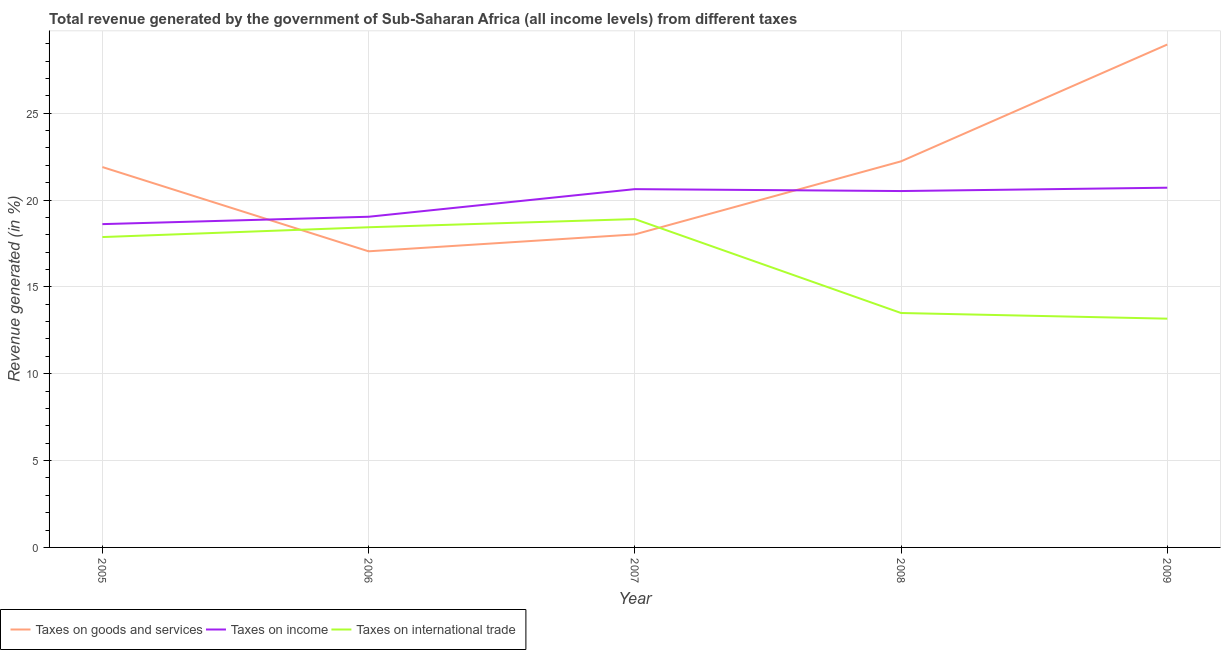Is the number of lines equal to the number of legend labels?
Offer a terse response. Yes. What is the percentage of revenue generated by taxes on income in 2006?
Make the answer very short. 19.04. Across all years, what is the maximum percentage of revenue generated by taxes on goods and services?
Provide a short and direct response. 28.95. Across all years, what is the minimum percentage of revenue generated by taxes on goods and services?
Your answer should be compact. 17.05. What is the total percentage of revenue generated by tax on international trade in the graph?
Your answer should be compact. 81.87. What is the difference between the percentage of revenue generated by taxes on income in 2006 and that in 2008?
Your response must be concise. -1.48. What is the difference between the percentage of revenue generated by taxes on income in 2008 and the percentage of revenue generated by tax on international trade in 2006?
Your response must be concise. 2.08. What is the average percentage of revenue generated by taxes on goods and services per year?
Your answer should be very brief. 21.63. In the year 2008, what is the difference between the percentage of revenue generated by taxes on goods and services and percentage of revenue generated by tax on international trade?
Provide a short and direct response. 8.73. What is the ratio of the percentage of revenue generated by taxes on goods and services in 2007 to that in 2009?
Your response must be concise. 0.62. What is the difference between the highest and the second highest percentage of revenue generated by tax on international trade?
Make the answer very short. 0.47. What is the difference between the highest and the lowest percentage of revenue generated by taxes on income?
Provide a succinct answer. 2.1. How many lines are there?
Give a very brief answer. 3. How many years are there in the graph?
Your answer should be very brief. 5. Are the values on the major ticks of Y-axis written in scientific E-notation?
Your answer should be very brief. No. Does the graph contain any zero values?
Your answer should be very brief. No. Where does the legend appear in the graph?
Provide a succinct answer. Bottom left. How many legend labels are there?
Ensure brevity in your answer.  3. How are the legend labels stacked?
Give a very brief answer. Horizontal. What is the title of the graph?
Provide a short and direct response. Total revenue generated by the government of Sub-Saharan Africa (all income levels) from different taxes. What is the label or title of the Y-axis?
Offer a terse response. Revenue generated (in %). What is the Revenue generated (in %) of Taxes on goods and services in 2005?
Ensure brevity in your answer.  21.9. What is the Revenue generated (in %) in Taxes on income in 2005?
Provide a short and direct response. 18.61. What is the Revenue generated (in %) in Taxes on international trade in 2005?
Provide a succinct answer. 17.87. What is the Revenue generated (in %) in Taxes on goods and services in 2006?
Ensure brevity in your answer.  17.05. What is the Revenue generated (in %) in Taxes on income in 2006?
Your response must be concise. 19.04. What is the Revenue generated (in %) in Taxes on international trade in 2006?
Make the answer very short. 18.43. What is the Revenue generated (in %) of Taxes on goods and services in 2007?
Your answer should be compact. 18.02. What is the Revenue generated (in %) of Taxes on income in 2007?
Provide a short and direct response. 20.63. What is the Revenue generated (in %) in Taxes on international trade in 2007?
Ensure brevity in your answer.  18.9. What is the Revenue generated (in %) of Taxes on goods and services in 2008?
Offer a terse response. 22.23. What is the Revenue generated (in %) in Taxes on income in 2008?
Give a very brief answer. 20.52. What is the Revenue generated (in %) in Taxes on international trade in 2008?
Your answer should be compact. 13.5. What is the Revenue generated (in %) in Taxes on goods and services in 2009?
Give a very brief answer. 28.95. What is the Revenue generated (in %) in Taxes on income in 2009?
Your answer should be compact. 20.71. What is the Revenue generated (in %) in Taxes on international trade in 2009?
Provide a short and direct response. 13.17. Across all years, what is the maximum Revenue generated (in %) of Taxes on goods and services?
Your answer should be compact. 28.95. Across all years, what is the maximum Revenue generated (in %) in Taxes on income?
Make the answer very short. 20.71. Across all years, what is the maximum Revenue generated (in %) of Taxes on international trade?
Provide a short and direct response. 18.9. Across all years, what is the minimum Revenue generated (in %) in Taxes on goods and services?
Provide a succinct answer. 17.05. Across all years, what is the minimum Revenue generated (in %) of Taxes on income?
Make the answer very short. 18.61. Across all years, what is the minimum Revenue generated (in %) of Taxes on international trade?
Your answer should be compact. 13.17. What is the total Revenue generated (in %) in Taxes on goods and services in the graph?
Offer a very short reply. 108.14. What is the total Revenue generated (in %) in Taxes on income in the graph?
Offer a very short reply. 99.5. What is the total Revenue generated (in %) of Taxes on international trade in the graph?
Provide a short and direct response. 81.87. What is the difference between the Revenue generated (in %) in Taxes on goods and services in 2005 and that in 2006?
Keep it short and to the point. 4.85. What is the difference between the Revenue generated (in %) of Taxes on income in 2005 and that in 2006?
Offer a very short reply. -0.42. What is the difference between the Revenue generated (in %) of Taxes on international trade in 2005 and that in 2006?
Keep it short and to the point. -0.57. What is the difference between the Revenue generated (in %) in Taxes on goods and services in 2005 and that in 2007?
Give a very brief answer. 3.88. What is the difference between the Revenue generated (in %) in Taxes on income in 2005 and that in 2007?
Your answer should be very brief. -2.01. What is the difference between the Revenue generated (in %) in Taxes on international trade in 2005 and that in 2007?
Ensure brevity in your answer.  -1.04. What is the difference between the Revenue generated (in %) of Taxes on goods and services in 2005 and that in 2008?
Provide a short and direct response. -0.33. What is the difference between the Revenue generated (in %) in Taxes on income in 2005 and that in 2008?
Your answer should be compact. -1.9. What is the difference between the Revenue generated (in %) of Taxes on international trade in 2005 and that in 2008?
Provide a short and direct response. 4.37. What is the difference between the Revenue generated (in %) in Taxes on goods and services in 2005 and that in 2009?
Your answer should be compact. -7.05. What is the difference between the Revenue generated (in %) in Taxes on income in 2005 and that in 2009?
Your answer should be very brief. -2.1. What is the difference between the Revenue generated (in %) of Taxes on international trade in 2005 and that in 2009?
Your response must be concise. 4.7. What is the difference between the Revenue generated (in %) of Taxes on goods and services in 2006 and that in 2007?
Keep it short and to the point. -0.97. What is the difference between the Revenue generated (in %) of Taxes on income in 2006 and that in 2007?
Keep it short and to the point. -1.59. What is the difference between the Revenue generated (in %) of Taxes on international trade in 2006 and that in 2007?
Make the answer very short. -0.47. What is the difference between the Revenue generated (in %) in Taxes on goods and services in 2006 and that in 2008?
Offer a terse response. -5.18. What is the difference between the Revenue generated (in %) in Taxes on income in 2006 and that in 2008?
Your response must be concise. -1.48. What is the difference between the Revenue generated (in %) in Taxes on international trade in 2006 and that in 2008?
Ensure brevity in your answer.  4.94. What is the difference between the Revenue generated (in %) of Taxes on goods and services in 2006 and that in 2009?
Make the answer very short. -11.9. What is the difference between the Revenue generated (in %) of Taxes on income in 2006 and that in 2009?
Provide a succinct answer. -1.67. What is the difference between the Revenue generated (in %) in Taxes on international trade in 2006 and that in 2009?
Offer a very short reply. 5.26. What is the difference between the Revenue generated (in %) of Taxes on goods and services in 2007 and that in 2008?
Your answer should be compact. -4.21. What is the difference between the Revenue generated (in %) of Taxes on income in 2007 and that in 2008?
Make the answer very short. 0.11. What is the difference between the Revenue generated (in %) of Taxes on international trade in 2007 and that in 2008?
Your answer should be very brief. 5.41. What is the difference between the Revenue generated (in %) in Taxes on goods and services in 2007 and that in 2009?
Your response must be concise. -10.93. What is the difference between the Revenue generated (in %) of Taxes on income in 2007 and that in 2009?
Your response must be concise. -0.08. What is the difference between the Revenue generated (in %) of Taxes on international trade in 2007 and that in 2009?
Offer a very short reply. 5.73. What is the difference between the Revenue generated (in %) of Taxes on goods and services in 2008 and that in 2009?
Provide a short and direct response. -6.72. What is the difference between the Revenue generated (in %) of Taxes on income in 2008 and that in 2009?
Make the answer very short. -0.19. What is the difference between the Revenue generated (in %) in Taxes on international trade in 2008 and that in 2009?
Your answer should be compact. 0.33. What is the difference between the Revenue generated (in %) of Taxes on goods and services in 2005 and the Revenue generated (in %) of Taxes on income in 2006?
Offer a terse response. 2.86. What is the difference between the Revenue generated (in %) of Taxes on goods and services in 2005 and the Revenue generated (in %) of Taxes on international trade in 2006?
Offer a very short reply. 3.47. What is the difference between the Revenue generated (in %) in Taxes on income in 2005 and the Revenue generated (in %) in Taxes on international trade in 2006?
Offer a very short reply. 0.18. What is the difference between the Revenue generated (in %) in Taxes on goods and services in 2005 and the Revenue generated (in %) in Taxes on income in 2007?
Your answer should be very brief. 1.27. What is the difference between the Revenue generated (in %) of Taxes on goods and services in 2005 and the Revenue generated (in %) of Taxes on international trade in 2007?
Offer a very short reply. 3. What is the difference between the Revenue generated (in %) in Taxes on income in 2005 and the Revenue generated (in %) in Taxes on international trade in 2007?
Provide a succinct answer. -0.29. What is the difference between the Revenue generated (in %) in Taxes on goods and services in 2005 and the Revenue generated (in %) in Taxes on income in 2008?
Make the answer very short. 1.38. What is the difference between the Revenue generated (in %) in Taxes on goods and services in 2005 and the Revenue generated (in %) in Taxes on international trade in 2008?
Provide a succinct answer. 8.4. What is the difference between the Revenue generated (in %) in Taxes on income in 2005 and the Revenue generated (in %) in Taxes on international trade in 2008?
Provide a succinct answer. 5.12. What is the difference between the Revenue generated (in %) in Taxes on goods and services in 2005 and the Revenue generated (in %) in Taxes on income in 2009?
Keep it short and to the point. 1.19. What is the difference between the Revenue generated (in %) in Taxes on goods and services in 2005 and the Revenue generated (in %) in Taxes on international trade in 2009?
Keep it short and to the point. 8.73. What is the difference between the Revenue generated (in %) in Taxes on income in 2005 and the Revenue generated (in %) in Taxes on international trade in 2009?
Offer a very short reply. 5.44. What is the difference between the Revenue generated (in %) in Taxes on goods and services in 2006 and the Revenue generated (in %) in Taxes on income in 2007?
Offer a very short reply. -3.58. What is the difference between the Revenue generated (in %) in Taxes on goods and services in 2006 and the Revenue generated (in %) in Taxes on international trade in 2007?
Make the answer very short. -1.86. What is the difference between the Revenue generated (in %) of Taxes on income in 2006 and the Revenue generated (in %) of Taxes on international trade in 2007?
Your answer should be very brief. 0.13. What is the difference between the Revenue generated (in %) of Taxes on goods and services in 2006 and the Revenue generated (in %) of Taxes on income in 2008?
Offer a very short reply. -3.47. What is the difference between the Revenue generated (in %) of Taxes on goods and services in 2006 and the Revenue generated (in %) of Taxes on international trade in 2008?
Offer a terse response. 3.55. What is the difference between the Revenue generated (in %) of Taxes on income in 2006 and the Revenue generated (in %) of Taxes on international trade in 2008?
Offer a very short reply. 5.54. What is the difference between the Revenue generated (in %) in Taxes on goods and services in 2006 and the Revenue generated (in %) in Taxes on income in 2009?
Offer a very short reply. -3.66. What is the difference between the Revenue generated (in %) of Taxes on goods and services in 2006 and the Revenue generated (in %) of Taxes on international trade in 2009?
Provide a short and direct response. 3.88. What is the difference between the Revenue generated (in %) of Taxes on income in 2006 and the Revenue generated (in %) of Taxes on international trade in 2009?
Ensure brevity in your answer.  5.87. What is the difference between the Revenue generated (in %) in Taxes on goods and services in 2007 and the Revenue generated (in %) in Taxes on income in 2008?
Provide a short and direct response. -2.5. What is the difference between the Revenue generated (in %) in Taxes on goods and services in 2007 and the Revenue generated (in %) in Taxes on international trade in 2008?
Offer a terse response. 4.52. What is the difference between the Revenue generated (in %) in Taxes on income in 2007 and the Revenue generated (in %) in Taxes on international trade in 2008?
Offer a very short reply. 7.13. What is the difference between the Revenue generated (in %) of Taxes on goods and services in 2007 and the Revenue generated (in %) of Taxes on income in 2009?
Ensure brevity in your answer.  -2.69. What is the difference between the Revenue generated (in %) in Taxes on goods and services in 2007 and the Revenue generated (in %) in Taxes on international trade in 2009?
Offer a terse response. 4.85. What is the difference between the Revenue generated (in %) of Taxes on income in 2007 and the Revenue generated (in %) of Taxes on international trade in 2009?
Make the answer very short. 7.46. What is the difference between the Revenue generated (in %) of Taxes on goods and services in 2008 and the Revenue generated (in %) of Taxes on income in 2009?
Give a very brief answer. 1.52. What is the difference between the Revenue generated (in %) in Taxes on goods and services in 2008 and the Revenue generated (in %) in Taxes on international trade in 2009?
Ensure brevity in your answer.  9.06. What is the difference between the Revenue generated (in %) in Taxes on income in 2008 and the Revenue generated (in %) in Taxes on international trade in 2009?
Make the answer very short. 7.35. What is the average Revenue generated (in %) of Taxes on goods and services per year?
Offer a very short reply. 21.63. What is the average Revenue generated (in %) of Taxes on income per year?
Provide a succinct answer. 19.9. What is the average Revenue generated (in %) of Taxes on international trade per year?
Keep it short and to the point. 16.37. In the year 2005, what is the difference between the Revenue generated (in %) in Taxes on goods and services and Revenue generated (in %) in Taxes on income?
Provide a succinct answer. 3.29. In the year 2005, what is the difference between the Revenue generated (in %) in Taxes on goods and services and Revenue generated (in %) in Taxes on international trade?
Provide a short and direct response. 4.03. In the year 2005, what is the difference between the Revenue generated (in %) in Taxes on income and Revenue generated (in %) in Taxes on international trade?
Your answer should be very brief. 0.75. In the year 2006, what is the difference between the Revenue generated (in %) of Taxes on goods and services and Revenue generated (in %) of Taxes on income?
Give a very brief answer. -1.99. In the year 2006, what is the difference between the Revenue generated (in %) in Taxes on goods and services and Revenue generated (in %) in Taxes on international trade?
Offer a terse response. -1.39. In the year 2006, what is the difference between the Revenue generated (in %) in Taxes on income and Revenue generated (in %) in Taxes on international trade?
Offer a terse response. 0.6. In the year 2007, what is the difference between the Revenue generated (in %) of Taxes on goods and services and Revenue generated (in %) of Taxes on income?
Your answer should be very brief. -2.61. In the year 2007, what is the difference between the Revenue generated (in %) in Taxes on goods and services and Revenue generated (in %) in Taxes on international trade?
Provide a short and direct response. -0.88. In the year 2007, what is the difference between the Revenue generated (in %) in Taxes on income and Revenue generated (in %) in Taxes on international trade?
Your answer should be very brief. 1.72. In the year 2008, what is the difference between the Revenue generated (in %) of Taxes on goods and services and Revenue generated (in %) of Taxes on income?
Provide a short and direct response. 1.71. In the year 2008, what is the difference between the Revenue generated (in %) of Taxes on goods and services and Revenue generated (in %) of Taxes on international trade?
Offer a terse response. 8.73. In the year 2008, what is the difference between the Revenue generated (in %) in Taxes on income and Revenue generated (in %) in Taxes on international trade?
Provide a short and direct response. 7.02. In the year 2009, what is the difference between the Revenue generated (in %) of Taxes on goods and services and Revenue generated (in %) of Taxes on income?
Give a very brief answer. 8.24. In the year 2009, what is the difference between the Revenue generated (in %) of Taxes on goods and services and Revenue generated (in %) of Taxes on international trade?
Offer a very short reply. 15.78. In the year 2009, what is the difference between the Revenue generated (in %) of Taxes on income and Revenue generated (in %) of Taxes on international trade?
Ensure brevity in your answer.  7.54. What is the ratio of the Revenue generated (in %) in Taxes on goods and services in 2005 to that in 2006?
Provide a short and direct response. 1.28. What is the ratio of the Revenue generated (in %) of Taxes on income in 2005 to that in 2006?
Your answer should be very brief. 0.98. What is the ratio of the Revenue generated (in %) of Taxes on international trade in 2005 to that in 2006?
Offer a very short reply. 0.97. What is the ratio of the Revenue generated (in %) in Taxes on goods and services in 2005 to that in 2007?
Keep it short and to the point. 1.22. What is the ratio of the Revenue generated (in %) in Taxes on income in 2005 to that in 2007?
Your response must be concise. 0.9. What is the ratio of the Revenue generated (in %) in Taxes on international trade in 2005 to that in 2007?
Give a very brief answer. 0.95. What is the ratio of the Revenue generated (in %) of Taxes on goods and services in 2005 to that in 2008?
Ensure brevity in your answer.  0.99. What is the ratio of the Revenue generated (in %) in Taxes on income in 2005 to that in 2008?
Your answer should be compact. 0.91. What is the ratio of the Revenue generated (in %) in Taxes on international trade in 2005 to that in 2008?
Your answer should be very brief. 1.32. What is the ratio of the Revenue generated (in %) of Taxes on goods and services in 2005 to that in 2009?
Provide a succinct answer. 0.76. What is the ratio of the Revenue generated (in %) of Taxes on income in 2005 to that in 2009?
Your response must be concise. 0.9. What is the ratio of the Revenue generated (in %) in Taxes on international trade in 2005 to that in 2009?
Your answer should be very brief. 1.36. What is the ratio of the Revenue generated (in %) of Taxes on goods and services in 2006 to that in 2007?
Offer a terse response. 0.95. What is the ratio of the Revenue generated (in %) of Taxes on income in 2006 to that in 2007?
Keep it short and to the point. 0.92. What is the ratio of the Revenue generated (in %) in Taxes on international trade in 2006 to that in 2007?
Your answer should be very brief. 0.98. What is the ratio of the Revenue generated (in %) in Taxes on goods and services in 2006 to that in 2008?
Offer a very short reply. 0.77. What is the ratio of the Revenue generated (in %) of Taxes on income in 2006 to that in 2008?
Offer a very short reply. 0.93. What is the ratio of the Revenue generated (in %) in Taxes on international trade in 2006 to that in 2008?
Offer a very short reply. 1.37. What is the ratio of the Revenue generated (in %) in Taxes on goods and services in 2006 to that in 2009?
Make the answer very short. 0.59. What is the ratio of the Revenue generated (in %) in Taxes on income in 2006 to that in 2009?
Make the answer very short. 0.92. What is the ratio of the Revenue generated (in %) in Taxes on international trade in 2006 to that in 2009?
Provide a succinct answer. 1.4. What is the ratio of the Revenue generated (in %) in Taxes on goods and services in 2007 to that in 2008?
Make the answer very short. 0.81. What is the ratio of the Revenue generated (in %) in Taxes on income in 2007 to that in 2008?
Provide a short and direct response. 1.01. What is the ratio of the Revenue generated (in %) of Taxes on international trade in 2007 to that in 2008?
Provide a succinct answer. 1.4. What is the ratio of the Revenue generated (in %) in Taxes on goods and services in 2007 to that in 2009?
Ensure brevity in your answer.  0.62. What is the ratio of the Revenue generated (in %) of Taxes on income in 2007 to that in 2009?
Offer a terse response. 1. What is the ratio of the Revenue generated (in %) in Taxes on international trade in 2007 to that in 2009?
Your answer should be compact. 1.44. What is the ratio of the Revenue generated (in %) of Taxes on goods and services in 2008 to that in 2009?
Make the answer very short. 0.77. What is the ratio of the Revenue generated (in %) of Taxes on income in 2008 to that in 2009?
Provide a succinct answer. 0.99. What is the ratio of the Revenue generated (in %) in Taxes on international trade in 2008 to that in 2009?
Keep it short and to the point. 1.02. What is the difference between the highest and the second highest Revenue generated (in %) of Taxes on goods and services?
Your answer should be compact. 6.72. What is the difference between the highest and the second highest Revenue generated (in %) in Taxes on income?
Your answer should be very brief. 0.08. What is the difference between the highest and the second highest Revenue generated (in %) of Taxes on international trade?
Ensure brevity in your answer.  0.47. What is the difference between the highest and the lowest Revenue generated (in %) in Taxes on goods and services?
Your answer should be compact. 11.9. What is the difference between the highest and the lowest Revenue generated (in %) in Taxes on income?
Your response must be concise. 2.1. What is the difference between the highest and the lowest Revenue generated (in %) of Taxes on international trade?
Your answer should be compact. 5.73. 